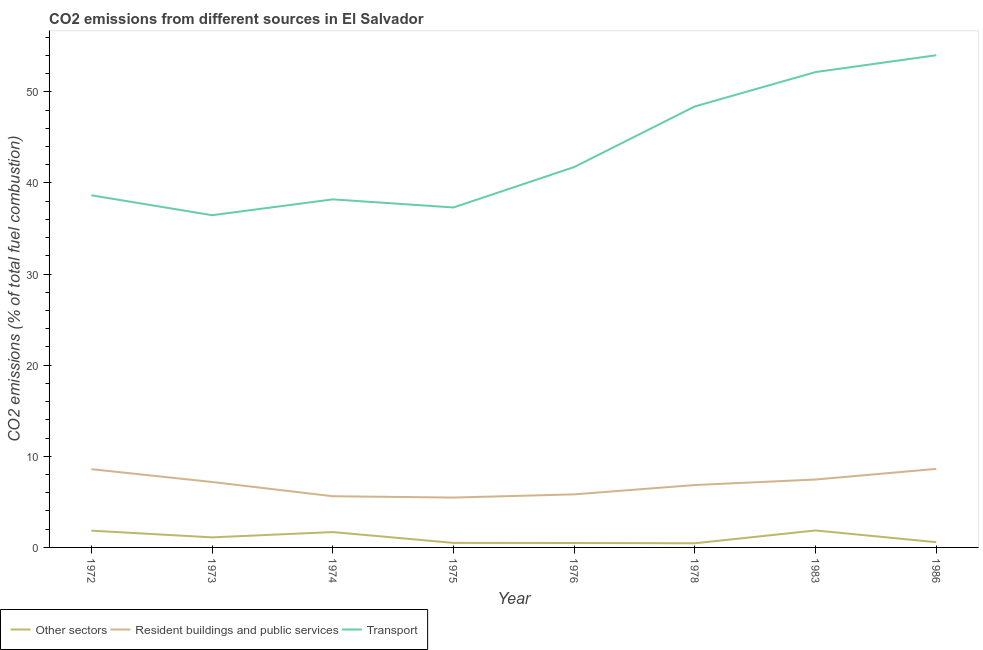How many different coloured lines are there?
Your answer should be compact. 3. Does the line corresponding to percentage of co2 emissions from transport intersect with the line corresponding to percentage of co2 emissions from other sectors?
Keep it short and to the point. No. What is the percentage of co2 emissions from other sectors in 1976?
Your answer should be very brief. 0.49. Across all years, what is the maximum percentage of co2 emissions from resident buildings and public services?
Your answer should be very brief. 8.62. Across all years, what is the minimum percentage of co2 emissions from resident buildings and public services?
Your answer should be very brief. 5.47. In which year was the percentage of co2 emissions from resident buildings and public services minimum?
Ensure brevity in your answer.  1975. What is the total percentage of co2 emissions from transport in the graph?
Ensure brevity in your answer.  346.98. What is the difference between the percentage of co2 emissions from transport in 1978 and that in 1986?
Offer a terse response. -5.62. What is the difference between the percentage of co2 emissions from resident buildings and public services in 1986 and the percentage of co2 emissions from other sectors in 1975?
Provide a succinct answer. 8.12. What is the average percentage of co2 emissions from resident buildings and public services per year?
Your response must be concise. 6.95. In the year 1972, what is the difference between the percentage of co2 emissions from resident buildings and public services and percentage of co2 emissions from other sectors?
Your response must be concise. 6.75. In how many years, is the percentage of co2 emissions from resident buildings and public services greater than 12 %?
Your answer should be very brief. 0. What is the ratio of the percentage of co2 emissions from transport in 1974 to that in 1983?
Offer a terse response. 0.73. Is the percentage of co2 emissions from transport in 1972 less than that in 1986?
Give a very brief answer. Yes. What is the difference between the highest and the second highest percentage of co2 emissions from other sectors?
Give a very brief answer. 0.02. What is the difference between the highest and the lowest percentage of co2 emissions from other sectors?
Ensure brevity in your answer.  1.41. In how many years, is the percentage of co2 emissions from resident buildings and public services greater than the average percentage of co2 emissions from resident buildings and public services taken over all years?
Give a very brief answer. 4. Is it the case that in every year, the sum of the percentage of co2 emissions from other sectors and percentage of co2 emissions from resident buildings and public services is greater than the percentage of co2 emissions from transport?
Give a very brief answer. No. Does the percentage of co2 emissions from transport monotonically increase over the years?
Offer a terse response. No. Is the percentage of co2 emissions from resident buildings and public services strictly greater than the percentage of co2 emissions from other sectors over the years?
Offer a terse response. Yes. Is the percentage of co2 emissions from other sectors strictly less than the percentage of co2 emissions from transport over the years?
Keep it short and to the point. Yes. How many years are there in the graph?
Give a very brief answer. 8. Does the graph contain any zero values?
Offer a very short reply. No. Does the graph contain grids?
Ensure brevity in your answer.  No. Where does the legend appear in the graph?
Your answer should be very brief. Bottom left. How many legend labels are there?
Offer a very short reply. 3. What is the title of the graph?
Ensure brevity in your answer.  CO2 emissions from different sources in El Salvador. What is the label or title of the Y-axis?
Your answer should be compact. CO2 emissions (% of total fuel combustion). What is the CO2 emissions (% of total fuel combustion) of Other sectors in 1972?
Provide a short and direct response. 1.84. What is the CO2 emissions (% of total fuel combustion) in Resident buildings and public services in 1972?
Offer a terse response. 8.59. What is the CO2 emissions (% of total fuel combustion) in Transport in 1972?
Offer a terse response. 38.65. What is the CO2 emissions (% of total fuel combustion) of Other sectors in 1973?
Provide a succinct answer. 1.1. What is the CO2 emissions (% of total fuel combustion) in Resident buildings and public services in 1973?
Your response must be concise. 7.18. What is the CO2 emissions (% of total fuel combustion) in Transport in 1973?
Give a very brief answer. 36.46. What is the CO2 emissions (% of total fuel combustion) in Other sectors in 1974?
Your answer should be compact. 1.69. What is the CO2 emissions (% of total fuel combustion) in Resident buildings and public services in 1974?
Give a very brief answer. 5.62. What is the CO2 emissions (% of total fuel combustion) in Transport in 1974?
Offer a terse response. 38.2. What is the CO2 emissions (% of total fuel combustion) of Other sectors in 1975?
Ensure brevity in your answer.  0.5. What is the CO2 emissions (% of total fuel combustion) of Resident buildings and public services in 1975?
Offer a terse response. 5.47. What is the CO2 emissions (% of total fuel combustion) in Transport in 1975?
Your answer should be very brief. 37.31. What is the CO2 emissions (% of total fuel combustion) of Other sectors in 1976?
Your answer should be compact. 0.49. What is the CO2 emissions (% of total fuel combustion) of Resident buildings and public services in 1976?
Provide a short and direct response. 5.83. What is the CO2 emissions (% of total fuel combustion) in Transport in 1976?
Your response must be concise. 41.75. What is the CO2 emissions (% of total fuel combustion) in Other sectors in 1978?
Offer a terse response. 0.46. What is the CO2 emissions (% of total fuel combustion) in Resident buildings and public services in 1978?
Provide a short and direct response. 6.85. What is the CO2 emissions (% of total fuel combustion) of Transport in 1978?
Your answer should be very brief. 48.4. What is the CO2 emissions (% of total fuel combustion) of Other sectors in 1983?
Make the answer very short. 1.86. What is the CO2 emissions (% of total fuel combustion) of Resident buildings and public services in 1983?
Offer a very short reply. 7.45. What is the CO2 emissions (% of total fuel combustion) of Transport in 1983?
Make the answer very short. 52.17. What is the CO2 emissions (% of total fuel combustion) in Other sectors in 1986?
Offer a terse response. 0.57. What is the CO2 emissions (% of total fuel combustion) in Resident buildings and public services in 1986?
Give a very brief answer. 8.62. What is the CO2 emissions (% of total fuel combustion) of Transport in 1986?
Give a very brief answer. 54.02. Across all years, what is the maximum CO2 emissions (% of total fuel combustion) in Other sectors?
Your answer should be very brief. 1.86. Across all years, what is the maximum CO2 emissions (% of total fuel combustion) of Resident buildings and public services?
Offer a very short reply. 8.62. Across all years, what is the maximum CO2 emissions (% of total fuel combustion) in Transport?
Give a very brief answer. 54.02. Across all years, what is the minimum CO2 emissions (% of total fuel combustion) of Other sectors?
Provide a short and direct response. 0.46. Across all years, what is the minimum CO2 emissions (% of total fuel combustion) in Resident buildings and public services?
Offer a very short reply. 5.47. Across all years, what is the minimum CO2 emissions (% of total fuel combustion) in Transport?
Your answer should be compact. 36.46. What is the total CO2 emissions (% of total fuel combustion) of Other sectors in the graph?
Offer a very short reply. 8.51. What is the total CO2 emissions (% of total fuel combustion) of Resident buildings and public services in the graph?
Provide a succinct answer. 55.61. What is the total CO2 emissions (% of total fuel combustion) of Transport in the graph?
Make the answer very short. 346.98. What is the difference between the CO2 emissions (% of total fuel combustion) of Other sectors in 1972 and that in 1973?
Provide a short and direct response. 0.74. What is the difference between the CO2 emissions (% of total fuel combustion) of Resident buildings and public services in 1972 and that in 1973?
Keep it short and to the point. 1.41. What is the difference between the CO2 emissions (% of total fuel combustion) of Transport in 1972 and that in 1973?
Provide a short and direct response. 2.19. What is the difference between the CO2 emissions (% of total fuel combustion) of Other sectors in 1972 and that in 1974?
Provide a short and direct response. 0.16. What is the difference between the CO2 emissions (% of total fuel combustion) of Resident buildings and public services in 1972 and that in 1974?
Make the answer very short. 2.97. What is the difference between the CO2 emissions (% of total fuel combustion) in Transport in 1972 and that in 1974?
Keep it short and to the point. 0.45. What is the difference between the CO2 emissions (% of total fuel combustion) of Other sectors in 1972 and that in 1975?
Ensure brevity in your answer.  1.34. What is the difference between the CO2 emissions (% of total fuel combustion) of Resident buildings and public services in 1972 and that in 1975?
Make the answer very short. 3.12. What is the difference between the CO2 emissions (% of total fuel combustion) in Transport in 1972 and that in 1975?
Keep it short and to the point. 1.34. What is the difference between the CO2 emissions (% of total fuel combustion) in Other sectors in 1972 and that in 1976?
Your answer should be very brief. 1.36. What is the difference between the CO2 emissions (% of total fuel combustion) in Resident buildings and public services in 1972 and that in 1976?
Ensure brevity in your answer.  2.76. What is the difference between the CO2 emissions (% of total fuel combustion) of Transport in 1972 and that in 1976?
Ensure brevity in your answer.  -3.1. What is the difference between the CO2 emissions (% of total fuel combustion) of Other sectors in 1972 and that in 1978?
Provide a succinct answer. 1.38. What is the difference between the CO2 emissions (% of total fuel combustion) in Resident buildings and public services in 1972 and that in 1978?
Offer a very short reply. 1.74. What is the difference between the CO2 emissions (% of total fuel combustion) of Transport in 1972 and that in 1978?
Provide a succinct answer. -9.75. What is the difference between the CO2 emissions (% of total fuel combustion) of Other sectors in 1972 and that in 1983?
Offer a terse response. -0.02. What is the difference between the CO2 emissions (% of total fuel combustion) of Resident buildings and public services in 1972 and that in 1983?
Make the answer very short. 1.14. What is the difference between the CO2 emissions (% of total fuel combustion) of Transport in 1972 and that in 1983?
Your answer should be very brief. -13.52. What is the difference between the CO2 emissions (% of total fuel combustion) of Other sectors in 1972 and that in 1986?
Offer a terse response. 1.27. What is the difference between the CO2 emissions (% of total fuel combustion) in Resident buildings and public services in 1972 and that in 1986?
Your answer should be very brief. -0.03. What is the difference between the CO2 emissions (% of total fuel combustion) in Transport in 1972 and that in 1986?
Provide a succinct answer. -15.37. What is the difference between the CO2 emissions (% of total fuel combustion) in Other sectors in 1973 and that in 1974?
Ensure brevity in your answer.  -0.58. What is the difference between the CO2 emissions (% of total fuel combustion) of Resident buildings and public services in 1973 and that in 1974?
Give a very brief answer. 1.56. What is the difference between the CO2 emissions (% of total fuel combustion) in Transport in 1973 and that in 1974?
Offer a terse response. -1.74. What is the difference between the CO2 emissions (% of total fuel combustion) of Other sectors in 1973 and that in 1975?
Keep it short and to the point. 0.61. What is the difference between the CO2 emissions (% of total fuel combustion) of Resident buildings and public services in 1973 and that in 1975?
Make the answer very short. 1.71. What is the difference between the CO2 emissions (% of total fuel combustion) of Transport in 1973 and that in 1975?
Make the answer very short. -0.85. What is the difference between the CO2 emissions (% of total fuel combustion) of Other sectors in 1973 and that in 1976?
Ensure brevity in your answer.  0.62. What is the difference between the CO2 emissions (% of total fuel combustion) in Resident buildings and public services in 1973 and that in 1976?
Ensure brevity in your answer.  1.36. What is the difference between the CO2 emissions (% of total fuel combustion) in Transport in 1973 and that in 1976?
Keep it short and to the point. -5.28. What is the difference between the CO2 emissions (% of total fuel combustion) in Other sectors in 1973 and that in 1978?
Your response must be concise. 0.65. What is the difference between the CO2 emissions (% of total fuel combustion) of Resident buildings and public services in 1973 and that in 1978?
Give a very brief answer. 0.33. What is the difference between the CO2 emissions (% of total fuel combustion) of Transport in 1973 and that in 1978?
Make the answer very short. -11.94. What is the difference between the CO2 emissions (% of total fuel combustion) of Other sectors in 1973 and that in 1983?
Ensure brevity in your answer.  -0.76. What is the difference between the CO2 emissions (% of total fuel combustion) of Resident buildings and public services in 1973 and that in 1983?
Provide a short and direct response. -0.27. What is the difference between the CO2 emissions (% of total fuel combustion) of Transport in 1973 and that in 1983?
Your answer should be compact. -15.71. What is the difference between the CO2 emissions (% of total fuel combustion) in Other sectors in 1973 and that in 1986?
Your answer should be compact. 0.53. What is the difference between the CO2 emissions (% of total fuel combustion) of Resident buildings and public services in 1973 and that in 1986?
Make the answer very short. -1.44. What is the difference between the CO2 emissions (% of total fuel combustion) of Transport in 1973 and that in 1986?
Offer a terse response. -17.56. What is the difference between the CO2 emissions (% of total fuel combustion) in Other sectors in 1974 and that in 1975?
Provide a short and direct response. 1.19. What is the difference between the CO2 emissions (% of total fuel combustion) of Resident buildings and public services in 1974 and that in 1975?
Offer a terse response. 0.15. What is the difference between the CO2 emissions (% of total fuel combustion) of Transport in 1974 and that in 1975?
Offer a very short reply. 0.89. What is the difference between the CO2 emissions (% of total fuel combustion) in Other sectors in 1974 and that in 1976?
Your answer should be compact. 1.2. What is the difference between the CO2 emissions (% of total fuel combustion) of Resident buildings and public services in 1974 and that in 1976?
Provide a succinct answer. -0.21. What is the difference between the CO2 emissions (% of total fuel combustion) of Transport in 1974 and that in 1976?
Keep it short and to the point. -3.55. What is the difference between the CO2 emissions (% of total fuel combustion) of Other sectors in 1974 and that in 1978?
Your answer should be very brief. 1.23. What is the difference between the CO2 emissions (% of total fuel combustion) of Resident buildings and public services in 1974 and that in 1978?
Keep it short and to the point. -1.23. What is the difference between the CO2 emissions (% of total fuel combustion) of Transport in 1974 and that in 1978?
Provide a short and direct response. -10.2. What is the difference between the CO2 emissions (% of total fuel combustion) of Other sectors in 1974 and that in 1983?
Your answer should be very brief. -0.18. What is the difference between the CO2 emissions (% of total fuel combustion) of Resident buildings and public services in 1974 and that in 1983?
Your answer should be compact. -1.84. What is the difference between the CO2 emissions (% of total fuel combustion) in Transport in 1974 and that in 1983?
Keep it short and to the point. -13.97. What is the difference between the CO2 emissions (% of total fuel combustion) in Other sectors in 1974 and that in 1986?
Ensure brevity in your answer.  1.11. What is the difference between the CO2 emissions (% of total fuel combustion) in Resident buildings and public services in 1974 and that in 1986?
Offer a very short reply. -3. What is the difference between the CO2 emissions (% of total fuel combustion) of Transport in 1974 and that in 1986?
Your response must be concise. -15.82. What is the difference between the CO2 emissions (% of total fuel combustion) of Other sectors in 1975 and that in 1976?
Your answer should be very brief. 0.01. What is the difference between the CO2 emissions (% of total fuel combustion) of Resident buildings and public services in 1975 and that in 1976?
Provide a short and direct response. -0.35. What is the difference between the CO2 emissions (% of total fuel combustion) of Transport in 1975 and that in 1976?
Your response must be concise. -4.43. What is the difference between the CO2 emissions (% of total fuel combustion) in Other sectors in 1975 and that in 1978?
Your response must be concise. 0.04. What is the difference between the CO2 emissions (% of total fuel combustion) in Resident buildings and public services in 1975 and that in 1978?
Offer a terse response. -1.38. What is the difference between the CO2 emissions (% of total fuel combustion) in Transport in 1975 and that in 1978?
Provide a succinct answer. -11.09. What is the difference between the CO2 emissions (% of total fuel combustion) in Other sectors in 1975 and that in 1983?
Give a very brief answer. -1.37. What is the difference between the CO2 emissions (% of total fuel combustion) in Resident buildings and public services in 1975 and that in 1983?
Provide a short and direct response. -1.98. What is the difference between the CO2 emissions (% of total fuel combustion) in Transport in 1975 and that in 1983?
Keep it short and to the point. -14.86. What is the difference between the CO2 emissions (% of total fuel combustion) in Other sectors in 1975 and that in 1986?
Make the answer very short. -0.08. What is the difference between the CO2 emissions (% of total fuel combustion) of Resident buildings and public services in 1975 and that in 1986?
Keep it short and to the point. -3.15. What is the difference between the CO2 emissions (% of total fuel combustion) in Transport in 1975 and that in 1986?
Your response must be concise. -16.71. What is the difference between the CO2 emissions (% of total fuel combustion) in Other sectors in 1976 and that in 1978?
Your response must be concise. 0.03. What is the difference between the CO2 emissions (% of total fuel combustion) in Resident buildings and public services in 1976 and that in 1978?
Give a very brief answer. -1.02. What is the difference between the CO2 emissions (% of total fuel combustion) of Transport in 1976 and that in 1978?
Your response must be concise. -6.65. What is the difference between the CO2 emissions (% of total fuel combustion) of Other sectors in 1976 and that in 1983?
Your answer should be compact. -1.38. What is the difference between the CO2 emissions (% of total fuel combustion) of Resident buildings and public services in 1976 and that in 1983?
Offer a terse response. -1.63. What is the difference between the CO2 emissions (% of total fuel combustion) in Transport in 1976 and that in 1983?
Your response must be concise. -10.43. What is the difference between the CO2 emissions (% of total fuel combustion) of Other sectors in 1976 and that in 1986?
Your answer should be very brief. -0.09. What is the difference between the CO2 emissions (% of total fuel combustion) in Resident buildings and public services in 1976 and that in 1986?
Offer a terse response. -2.8. What is the difference between the CO2 emissions (% of total fuel combustion) of Transport in 1976 and that in 1986?
Keep it short and to the point. -12.28. What is the difference between the CO2 emissions (% of total fuel combustion) in Other sectors in 1978 and that in 1983?
Offer a terse response. -1.41. What is the difference between the CO2 emissions (% of total fuel combustion) of Resident buildings and public services in 1978 and that in 1983?
Offer a very short reply. -0.6. What is the difference between the CO2 emissions (% of total fuel combustion) of Transport in 1978 and that in 1983?
Keep it short and to the point. -3.77. What is the difference between the CO2 emissions (% of total fuel combustion) of Other sectors in 1978 and that in 1986?
Offer a terse response. -0.12. What is the difference between the CO2 emissions (% of total fuel combustion) of Resident buildings and public services in 1978 and that in 1986?
Give a very brief answer. -1.77. What is the difference between the CO2 emissions (% of total fuel combustion) of Transport in 1978 and that in 1986?
Make the answer very short. -5.62. What is the difference between the CO2 emissions (% of total fuel combustion) in Other sectors in 1983 and that in 1986?
Offer a terse response. 1.29. What is the difference between the CO2 emissions (% of total fuel combustion) in Resident buildings and public services in 1983 and that in 1986?
Offer a very short reply. -1.17. What is the difference between the CO2 emissions (% of total fuel combustion) in Transport in 1983 and that in 1986?
Make the answer very short. -1.85. What is the difference between the CO2 emissions (% of total fuel combustion) of Other sectors in 1972 and the CO2 emissions (% of total fuel combustion) of Resident buildings and public services in 1973?
Ensure brevity in your answer.  -5.34. What is the difference between the CO2 emissions (% of total fuel combustion) of Other sectors in 1972 and the CO2 emissions (% of total fuel combustion) of Transport in 1973?
Ensure brevity in your answer.  -34.62. What is the difference between the CO2 emissions (% of total fuel combustion) of Resident buildings and public services in 1972 and the CO2 emissions (% of total fuel combustion) of Transport in 1973?
Offer a terse response. -27.88. What is the difference between the CO2 emissions (% of total fuel combustion) of Other sectors in 1972 and the CO2 emissions (% of total fuel combustion) of Resident buildings and public services in 1974?
Ensure brevity in your answer.  -3.78. What is the difference between the CO2 emissions (% of total fuel combustion) in Other sectors in 1972 and the CO2 emissions (% of total fuel combustion) in Transport in 1974?
Provide a succinct answer. -36.36. What is the difference between the CO2 emissions (% of total fuel combustion) of Resident buildings and public services in 1972 and the CO2 emissions (% of total fuel combustion) of Transport in 1974?
Offer a terse response. -29.61. What is the difference between the CO2 emissions (% of total fuel combustion) in Other sectors in 1972 and the CO2 emissions (% of total fuel combustion) in Resident buildings and public services in 1975?
Your answer should be compact. -3.63. What is the difference between the CO2 emissions (% of total fuel combustion) of Other sectors in 1972 and the CO2 emissions (% of total fuel combustion) of Transport in 1975?
Provide a short and direct response. -35.47. What is the difference between the CO2 emissions (% of total fuel combustion) in Resident buildings and public services in 1972 and the CO2 emissions (% of total fuel combustion) in Transport in 1975?
Keep it short and to the point. -28.72. What is the difference between the CO2 emissions (% of total fuel combustion) in Other sectors in 1972 and the CO2 emissions (% of total fuel combustion) in Resident buildings and public services in 1976?
Provide a short and direct response. -3.98. What is the difference between the CO2 emissions (% of total fuel combustion) in Other sectors in 1972 and the CO2 emissions (% of total fuel combustion) in Transport in 1976?
Your answer should be very brief. -39.91. What is the difference between the CO2 emissions (% of total fuel combustion) of Resident buildings and public services in 1972 and the CO2 emissions (% of total fuel combustion) of Transport in 1976?
Provide a short and direct response. -33.16. What is the difference between the CO2 emissions (% of total fuel combustion) of Other sectors in 1972 and the CO2 emissions (% of total fuel combustion) of Resident buildings and public services in 1978?
Offer a terse response. -5.01. What is the difference between the CO2 emissions (% of total fuel combustion) of Other sectors in 1972 and the CO2 emissions (% of total fuel combustion) of Transport in 1978?
Provide a short and direct response. -46.56. What is the difference between the CO2 emissions (% of total fuel combustion) in Resident buildings and public services in 1972 and the CO2 emissions (% of total fuel combustion) in Transport in 1978?
Ensure brevity in your answer.  -39.81. What is the difference between the CO2 emissions (% of total fuel combustion) of Other sectors in 1972 and the CO2 emissions (% of total fuel combustion) of Resident buildings and public services in 1983?
Give a very brief answer. -5.61. What is the difference between the CO2 emissions (% of total fuel combustion) of Other sectors in 1972 and the CO2 emissions (% of total fuel combustion) of Transport in 1983?
Provide a succinct answer. -50.33. What is the difference between the CO2 emissions (% of total fuel combustion) in Resident buildings and public services in 1972 and the CO2 emissions (% of total fuel combustion) in Transport in 1983?
Your answer should be very brief. -43.59. What is the difference between the CO2 emissions (% of total fuel combustion) in Other sectors in 1972 and the CO2 emissions (% of total fuel combustion) in Resident buildings and public services in 1986?
Your answer should be very brief. -6.78. What is the difference between the CO2 emissions (% of total fuel combustion) of Other sectors in 1972 and the CO2 emissions (% of total fuel combustion) of Transport in 1986?
Make the answer very short. -52.18. What is the difference between the CO2 emissions (% of total fuel combustion) in Resident buildings and public services in 1972 and the CO2 emissions (% of total fuel combustion) in Transport in 1986?
Your answer should be very brief. -45.43. What is the difference between the CO2 emissions (% of total fuel combustion) in Other sectors in 1973 and the CO2 emissions (% of total fuel combustion) in Resident buildings and public services in 1974?
Provide a short and direct response. -4.51. What is the difference between the CO2 emissions (% of total fuel combustion) in Other sectors in 1973 and the CO2 emissions (% of total fuel combustion) in Transport in 1974?
Keep it short and to the point. -37.1. What is the difference between the CO2 emissions (% of total fuel combustion) in Resident buildings and public services in 1973 and the CO2 emissions (% of total fuel combustion) in Transport in 1974?
Offer a terse response. -31.02. What is the difference between the CO2 emissions (% of total fuel combustion) in Other sectors in 1973 and the CO2 emissions (% of total fuel combustion) in Resident buildings and public services in 1975?
Offer a very short reply. -4.37. What is the difference between the CO2 emissions (% of total fuel combustion) of Other sectors in 1973 and the CO2 emissions (% of total fuel combustion) of Transport in 1975?
Ensure brevity in your answer.  -36.21. What is the difference between the CO2 emissions (% of total fuel combustion) in Resident buildings and public services in 1973 and the CO2 emissions (% of total fuel combustion) in Transport in 1975?
Your response must be concise. -30.13. What is the difference between the CO2 emissions (% of total fuel combustion) in Other sectors in 1973 and the CO2 emissions (% of total fuel combustion) in Resident buildings and public services in 1976?
Offer a terse response. -4.72. What is the difference between the CO2 emissions (% of total fuel combustion) of Other sectors in 1973 and the CO2 emissions (% of total fuel combustion) of Transport in 1976?
Ensure brevity in your answer.  -40.64. What is the difference between the CO2 emissions (% of total fuel combustion) of Resident buildings and public services in 1973 and the CO2 emissions (% of total fuel combustion) of Transport in 1976?
Your response must be concise. -34.57. What is the difference between the CO2 emissions (% of total fuel combustion) in Other sectors in 1973 and the CO2 emissions (% of total fuel combustion) in Resident buildings and public services in 1978?
Give a very brief answer. -5.74. What is the difference between the CO2 emissions (% of total fuel combustion) of Other sectors in 1973 and the CO2 emissions (% of total fuel combustion) of Transport in 1978?
Your answer should be very brief. -47.3. What is the difference between the CO2 emissions (% of total fuel combustion) of Resident buildings and public services in 1973 and the CO2 emissions (% of total fuel combustion) of Transport in 1978?
Ensure brevity in your answer.  -41.22. What is the difference between the CO2 emissions (% of total fuel combustion) of Other sectors in 1973 and the CO2 emissions (% of total fuel combustion) of Resident buildings and public services in 1983?
Offer a terse response. -6.35. What is the difference between the CO2 emissions (% of total fuel combustion) of Other sectors in 1973 and the CO2 emissions (% of total fuel combustion) of Transport in 1983?
Your response must be concise. -51.07. What is the difference between the CO2 emissions (% of total fuel combustion) of Resident buildings and public services in 1973 and the CO2 emissions (% of total fuel combustion) of Transport in 1983?
Offer a terse response. -44.99. What is the difference between the CO2 emissions (% of total fuel combustion) of Other sectors in 1973 and the CO2 emissions (% of total fuel combustion) of Resident buildings and public services in 1986?
Your answer should be compact. -7.52. What is the difference between the CO2 emissions (% of total fuel combustion) of Other sectors in 1973 and the CO2 emissions (% of total fuel combustion) of Transport in 1986?
Your response must be concise. -52.92. What is the difference between the CO2 emissions (% of total fuel combustion) in Resident buildings and public services in 1973 and the CO2 emissions (% of total fuel combustion) in Transport in 1986?
Offer a terse response. -46.84. What is the difference between the CO2 emissions (% of total fuel combustion) in Other sectors in 1974 and the CO2 emissions (% of total fuel combustion) in Resident buildings and public services in 1975?
Your answer should be compact. -3.79. What is the difference between the CO2 emissions (% of total fuel combustion) of Other sectors in 1974 and the CO2 emissions (% of total fuel combustion) of Transport in 1975?
Provide a short and direct response. -35.63. What is the difference between the CO2 emissions (% of total fuel combustion) in Resident buildings and public services in 1974 and the CO2 emissions (% of total fuel combustion) in Transport in 1975?
Your answer should be compact. -31.7. What is the difference between the CO2 emissions (% of total fuel combustion) of Other sectors in 1974 and the CO2 emissions (% of total fuel combustion) of Resident buildings and public services in 1976?
Give a very brief answer. -4.14. What is the difference between the CO2 emissions (% of total fuel combustion) of Other sectors in 1974 and the CO2 emissions (% of total fuel combustion) of Transport in 1976?
Provide a short and direct response. -40.06. What is the difference between the CO2 emissions (% of total fuel combustion) of Resident buildings and public services in 1974 and the CO2 emissions (% of total fuel combustion) of Transport in 1976?
Your response must be concise. -36.13. What is the difference between the CO2 emissions (% of total fuel combustion) of Other sectors in 1974 and the CO2 emissions (% of total fuel combustion) of Resident buildings and public services in 1978?
Your answer should be very brief. -5.16. What is the difference between the CO2 emissions (% of total fuel combustion) in Other sectors in 1974 and the CO2 emissions (% of total fuel combustion) in Transport in 1978?
Your answer should be compact. -46.72. What is the difference between the CO2 emissions (% of total fuel combustion) in Resident buildings and public services in 1974 and the CO2 emissions (% of total fuel combustion) in Transport in 1978?
Provide a succinct answer. -42.78. What is the difference between the CO2 emissions (% of total fuel combustion) of Other sectors in 1974 and the CO2 emissions (% of total fuel combustion) of Resident buildings and public services in 1983?
Offer a terse response. -5.77. What is the difference between the CO2 emissions (% of total fuel combustion) in Other sectors in 1974 and the CO2 emissions (% of total fuel combustion) in Transport in 1983?
Give a very brief answer. -50.49. What is the difference between the CO2 emissions (% of total fuel combustion) in Resident buildings and public services in 1974 and the CO2 emissions (% of total fuel combustion) in Transport in 1983?
Keep it short and to the point. -46.56. What is the difference between the CO2 emissions (% of total fuel combustion) in Other sectors in 1974 and the CO2 emissions (% of total fuel combustion) in Resident buildings and public services in 1986?
Offer a terse response. -6.94. What is the difference between the CO2 emissions (% of total fuel combustion) of Other sectors in 1974 and the CO2 emissions (% of total fuel combustion) of Transport in 1986?
Offer a terse response. -52.34. What is the difference between the CO2 emissions (% of total fuel combustion) in Resident buildings and public services in 1974 and the CO2 emissions (% of total fuel combustion) in Transport in 1986?
Provide a succinct answer. -48.41. What is the difference between the CO2 emissions (% of total fuel combustion) of Other sectors in 1975 and the CO2 emissions (% of total fuel combustion) of Resident buildings and public services in 1976?
Give a very brief answer. -5.33. What is the difference between the CO2 emissions (% of total fuel combustion) of Other sectors in 1975 and the CO2 emissions (% of total fuel combustion) of Transport in 1976?
Your answer should be compact. -41.25. What is the difference between the CO2 emissions (% of total fuel combustion) of Resident buildings and public services in 1975 and the CO2 emissions (% of total fuel combustion) of Transport in 1976?
Your answer should be very brief. -36.27. What is the difference between the CO2 emissions (% of total fuel combustion) in Other sectors in 1975 and the CO2 emissions (% of total fuel combustion) in Resident buildings and public services in 1978?
Make the answer very short. -6.35. What is the difference between the CO2 emissions (% of total fuel combustion) in Other sectors in 1975 and the CO2 emissions (% of total fuel combustion) in Transport in 1978?
Provide a short and direct response. -47.9. What is the difference between the CO2 emissions (% of total fuel combustion) in Resident buildings and public services in 1975 and the CO2 emissions (% of total fuel combustion) in Transport in 1978?
Ensure brevity in your answer.  -42.93. What is the difference between the CO2 emissions (% of total fuel combustion) of Other sectors in 1975 and the CO2 emissions (% of total fuel combustion) of Resident buildings and public services in 1983?
Keep it short and to the point. -6.96. What is the difference between the CO2 emissions (% of total fuel combustion) in Other sectors in 1975 and the CO2 emissions (% of total fuel combustion) in Transport in 1983?
Provide a short and direct response. -51.68. What is the difference between the CO2 emissions (% of total fuel combustion) in Resident buildings and public services in 1975 and the CO2 emissions (% of total fuel combustion) in Transport in 1983?
Your answer should be very brief. -46.7. What is the difference between the CO2 emissions (% of total fuel combustion) of Other sectors in 1975 and the CO2 emissions (% of total fuel combustion) of Resident buildings and public services in 1986?
Offer a very short reply. -8.12. What is the difference between the CO2 emissions (% of total fuel combustion) in Other sectors in 1975 and the CO2 emissions (% of total fuel combustion) in Transport in 1986?
Your response must be concise. -53.53. What is the difference between the CO2 emissions (% of total fuel combustion) in Resident buildings and public services in 1975 and the CO2 emissions (% of total fuel combustion) in Transport in 1986?
Offer a terse response. -48.55. What is the difference between the CO2 emissions (% of total fuel combustion) in Other sectors in 1976 and the CO2 emissions (% of total fuel combustion) in Resident buildings and public services in 1978?
Ensure brevity in your answer.  -6.36. What is the difference between the CO2 emissions (% of total fuel combustion) of Other sectors in 1976 and the CO2 emissions (% of total fuel combustion) of Transport in 1978?
Offer a terse response. -47.92. What is the difference between the CO2 emissions (% of total fuel combustion) of Resident buildings and public services in 1976 and the CO2 emissions (% of total fuel combustion) of Transport in 1978?
Offer a terse response. -42.58. What is the difference between the CO2 emissions (% of total fuel combustion) of Other sectors in 1976 and the CO2 emissions (% of total fuel combustion) of Resident buildings and public services in 1983?
Your answer should be compact. -6.97. What is the difference between the CO2 emissions (% of total fuel combustion) of Other sectors in 1976 and the CO2 emissions (% of total fuel combustion) of Transport in 1983?
Offer a terse response. -51.69. What is the difference between the CO2 emissions (% of total fuel combustion) in Resident buildings and public services in 1976 and the CO2 emissions (% of total fuel combustion) in Transport in 1983?
Provide a succinct answer. -46.35. What is the difference between the CO2 emissions (% of total fuel combustion) of Other sectors in 1976 and the CO2 emissions (% of total fuel combustion) of Resident buildings and public services in 1986?
Ensure brevity in your answer.  -8.14. What is the difference between the CO2 emissions (% of total fuel combustion) of Other sectors in 1976 and the CO2 emissions (% of total fuel combustion) of Transport in 1986?
Offer a very short reply. -53.54. What is the difference between the CO2 emissions (% of total fuel combustion) of Resident buildings and public services in 1976 and the CO2 emissions (% of total fuel combustion) of Transport in 1986?
Your answer should be compact. -48.2. What is the difference between the CO2 emissions (% of total fuel combustion) of Other sectors in 1978 and the CO2 emissions (% of total fuel combustion) of Resident buildings and public services in 1983?
Give a very brief answer. -7. What is the difference between the CO2 emissions (% of total fuel combustion) in Other sectors in 1978 and the CO2 emissions (% of total fuel combustion) in Transport in 1983?
Your answer should be compact. -51.72. What is the difference between the CO2 emissions (% of total fuel combustion) in Resident buildings and public services in 1978 and the CO2 emissions (% of total fuel combustion) in Transport in 1983?
Offer a very short reply. -45.32. What is the difference between the CO2 emissions (% of total fuel combustion) of Other sectors in 1978 and the CO2 emissions (% of total fuel combustion) of Resident buildings and public services in 1986?
Give a very brief answer. -8.16. What is the difference between the CO2 emissions (% of total fuel combustion) of Other sectors in 1978 and the CO2 emissions (% of total fuel combustion) of Transport in 1986?
Give a very brief answer. -53.57. What is the difference between the CO2 emissions (% of total fuel combustion) in Resident buildings and public services in 1978 and the CO2 emissions (% of total fuel combustion) in Transport in 1986?
Give a very brief answer. -47.17. What is the difference between the CO2 emissions (% of total fuel combustion) in Other sectors in 1983 and the CO2 emissions (% of total fuel combustion) in Resident buildings and public services in 1986?
Ensure brevity in your answer.  -6.76. What is the difference between the CO2 emissions (% of total fuel combustion) in Other sectors in 1983 and the CO2 emissions (% of total fuel combustion) in Transport in 1986?
Give a very brief answer. -52.16. What is the difference between the CO2 emissions (% of total fuel combustion) of Resident buildings and public services in 1983 and the CO2 emissions (% of total fuel combustion) of Transport in 1986?
Keep it short and to the point. -46.57. What is the average CO2 emissions (% of total fuel combustion) of Other sectors per year?
Keep it short and to the point. 1.06. What is the average CO2 emissions (% of total fuel combustion) of Resident buildings and public services per year?
Give a very brief answer. 6.95. What is the average CO2 emissions (% of total fuel combustion) in Transport per year?
Your response must be concise. 43.37. In the year 1972, what is the difference between the CO2 emissions (% of total fuel combustion) of Other sectors and CO2 emissions (% of total fuel combustion) of Resident buildings and public services?
Your answer should be very brief. -6.75. In the year 1972, what is the difference between the CO2 emissions (% of total fuel combustion) of Other sectors and CO2 emissions (% of total fuel combustion) of Transport?
Your answer should be very brief. -36.81. In the year 1972, what is the difference between the CO2 emissions (% of total fuel combustion) in Resident buildings and public services and CO2 emissions (% of total fuel combustion) in Transport?
Your response must be concise. -30.06. In the year 1973, what is the difference between the CO2 emissions (% of total fuel combustion) in Other sectors and CO2 emissions (% of total fuel combustion) in Resident buildings and public services?
Provide a short and direct response. -6.08. In the year 1973, what is the difference between the CO2 emissions (% of total fuel combustion) in Other sectors and CO2 emissions (% of total fuel combustion) in Transport?
Provide a succinct answer. -35.36. In the year 1973, what is the difference between the CO2 emissions (% of total fuel combustion) of Resident buildings and public services and CO2 emissions (% of total fuel combustion) of Transport?
Offer a very short reply. -29.28. In the year 1974, what is the difference between the CO2 emissions (% of total fuel combustion) in Other sectors and CO2 emissions (% of total fuel combustion) in Resident buildings and public services?
Offer a terse response. -3.93. In the year 1974, what is the difference between the CO2 emissions (% of total fuel combustion) of Other sectors and CO2 emissions (% of total fuel combustion) of Transport?
Provide a short and direct response. -36.52. In the year 1974, what is the difference between the CO2 emissions (% of total fuel combustion) of Resident buildings and public services and CO2 emissions (% of total fuel combustion) of Transport?
Keep it short and to the point. -32.58. In the year 1975, what is the difference between the CO2 emissions (% of total fuel combustion) of Other sectors and CO2 emissions (% of total fuel combustion) of Resident buildings and public services?
Your response must be concise. -4.98. In the year 1975, what is the difference between the CO2 emissions (% of total fuel combustion) of Other sectors and CO2 emissions (% of total fuel combustion) of Transport?
Provide a short and direct response. -36.82. In the year 1975, what is the difference between the CO2 emissions (% of total fuel combustion) of Resident buildings and public services and CO2 emissions (% of total fuel combustion) of Transport?
Give a very brief answer. -31.84. In the year 1976, what is the difference between the CO2 emissions (% of total fuel combustion) in Other sectors and CO2 emissions (% of total fuel combustion) in Resident buildings and public services?
Offer a very short reply. -5.34. In the year 1976, what is the difference between the CO2 emissions (% of total fuel combustion) of Other sectors and CO2 emissions (% of total fuel combustion) of Transport?
Provide a succinct answer. -41.26. In the year 1976, what is the difference between the CO2 emissions (% of total fuel combustion) of Resident buildings and public services and CO2 emissions (% of total fuel combustion) of Transport?
Ensure brevity in your answer.  -35.92. In the year 1978, what is the difference between the CO2 emissions (% of total fuel combustion) of Other sectors and CO2 emissions (% of total fuel combustion) of Resident buildings and public services?
Make the answer very short. -6.39. In the year 1978, what is the difference between the CO2 emissions (% of total fuel combustion) in Other sectors and CO2 emissions (% of total fuel combustion) in Transport?
Offer a very short reply. -47.95. In the year 1978, what is the difference between the CO2 emissions (% of total fuel combustion) of Resident buildings and public services and CO2 emissions (% of total fuel combustion) of Transport?
Provide a succinct answer. -41.55. In the year 1983, what is the difference between the CO2 emissions (% of total fuel combustion) of Other sectors and CO2 emissions (% of total fuel combustion) of Resident buildings and public services?
Offer a terse response. -5.59. In the year 1983, what is the difference between the CO2 emissions (% of total fuel combustion) in Other sectors and CO2 emissions (% of total fuel combustion) in Transport?
Give a very brief answer. -50.31. In the year 1983, what is the difference between the CO2 emissions (% of total fuel combustion) of Resident buildings and public services and CO2 emissions (% of total fuel combustion) of Transport?
Provide a short and direct response. -44.72. In the year 1986, what is the difference between the CO2 emissions (% of total fuel combustion) in Other sectors and CO2 emissions (% of total fuel combustion) in Resident buildings and public services?
Make the answer very short. -8.05. In the year 1986, what is the difference between the CO2 emissions (% of total fuel combustion) in Other sectors and CO2 emissions (% of total fuel combustion) in Transport?
Keep it short and to the point. -53.45. In the year 1986, what is the difference between the CO2 emissions (% of total fuel combustion) in Resident buildings and public services and CO2 emissions (% of total fuel combustion) in Transport?
Keep it short and to the point. -45.4. What is the ratio of the CO2 emissions (% of total fuel combustion) of Other sectors in 1972 to that in 1973?
Your answer should be very brief. 1.67. What is the ratio of the CO2 emissions (% of total fuel combustion) in Resident buildings and public services in 1972 to that in 1973?
Your response must be concise. 1.2. What is the ratio of the CO2 emissions (% of total fuel combustion) in Transport in 1972 to that in 1973?
Offer a terse response. 1.06. What is the ratio of the CO2 emissions (% of total fuel combustion) of Other sectors in 1972 to that in 1974?
Ensure brevity in your answer.  1.09. What is the ratio of the CO2 emissions (% of total fuel combustion) in Resident buildings and public services in 1972 to that in 1974?
Ensure brevity in your answer.  1.53. What is the ratio of the CO2 emissions (% of total fuel combustion) of Transport in 1972 to that in 1974?
Your answer should be very brief. 1.01. What is the ratio of the CO2 emissions (% of total fuel combustion) of Other sectors in 1972 to that in 1975?
Your answer should be compact. 3.7. What is the ratio of the CO2 emissions (% of total fuel combustion) in Resident buildings and public services in 1972 to that in 1975?
Offer a very short reply. 1.57. What is the ratio of the CO2 emissions (% of total fuel combustion) in Transport in 1972 to that in 1975?
Make the answer very short. 1.04. What is the ratio of the CO2 emissions (% of total fuel combustion) of Other sectors in 1972 to that in 1976?
Offer a terse response. 3.79. What is the ratio of the CO2 emissions (% of total fuel combustion) in Resident buildings and public services in 1972 to that in 1976?
Your answer should be very brief. 1.47. What is the ratio of the CO2 emissions (% of total fuel combustion) of Transport in 1972 to that in 1976?
Keep it short and to the point. 0.93. What is the ratio of the CO2 emissions (% of total fuel combustion) in Other sectors in 1972 to that in 1978?
Provide a succinct answer. 4.03. What is the ratio of the CO2 emissions (% of total fuel combustion) in Resident buildings and public services in 1972 to that in 1978?
Provide a succinct answer. 1.25. What is the ratio of the CO2 emissions (% of total fuel combustion) of Transport in 1972 to that in 1978?
Offer a very short reply. 0.8. What is the ratio of the CO2 emissions (% of total fuel combustion) of Other sectors in 1972 to that in 1983?
Provide a succinct answer. 0.99. What is the ratio of the CO2 emissions (% of total fuel combustion) of Resident buildings and public services in 1972 to that in 1983?
Give a very brief answer. 1.15. What is the ratio of the CO2 emissions (% of total fuel combustion) in Transport in 1972 to that in 1983?
Ensure brevity in your answer.  0.74. What is the ratio of the CO2 emissions (% of total fuel combustion) of Other sectors in 1972 to that in 1986?
Offer a terse response. 3.2. What is the ratio of the CO2 emissions (% of total fuel combustion) of Resident buildings and public services in 1972 to that in 1986?
Your answer should be very brief. 1. What is the ratio of the CO2 emissions (% of total fuel combustion) of Transport in 1972 to that in 1986?
Provide a short and direct response. 0.72. What is the ratio of the CO2 emissions (% of total fuel combustion) in Other sectors in 1973 to that in 1974?
Ensure brevity in your answer.  0.66. What is the ratio of the CO2 emissions (% of total fuel combustion) of Resident buildings and public services in 1973 to that in 1974?
Give a very brief answer. 1.28. What is the ratio of the CO2 emissions (% of total fuel combustion) in Transport in 1973 to that in 1974?
Your answer should be very brief. 0.95. What is the ratio of the CO2 emissions (% of total fuel combustion) in Other sectors in 1973 to that in 1975?
Offer a terse response. 2.22. What is the ratio of the CO2 emissions (% of total fuel combustion) in Resident buildings and public services in 1973 to that in 1975?
Offer a very short reply. 1.31. What is the ratio of the CO2 emissions (% of total fuel combustion) in Transport in 1973 to that in 1975?
Make the answer very short. 0.98. What is the ratio of the CO2 emissions (% of total fuel combustion) in Other sectors in 1973 to that in 1976?
Provide a succinct answer. 2.28. What is the ratio of the CO2 emissions (% of total fuel combustion) in Resident buildings and public services in 1973 to that in 1976?
Offer a very short reply. 1.23. What is the ratio of the CO2 emissions (% of total fuel combustion) of Transport in 1973 to that in 1976?
Your answer should be compact. 0.87. What is the ratio of the CO2 emissions (% of total fuel combustion) of Other sectors in 1973 to that in 1978?
Your answer should be compact. 2.42. What is the ratio of the CO2 emissions (% of total fuel combustion) of Resident buildings and public services in 1973 to that in 1978?
Make the answer very short. 1.05. What is the ratio of the CO2 emissions (% of total fuel combustion) in Transport in 1973 to that in 1978?
Give a very brief answer. 0.75. What is the ratio of the CO2 emissions (% of total fuel combustion) of Other sectors in 1973 to that in 1983?
Make the answer very short. 0.59. What is the ratio of the CO2 emissions (% of total fuel combustion) of Resident buildings and public services in 1973 to that in 1983?
Your answer should be compact. 0.96. What is the ratio of the CO2 emissions (% of total fuel combustion) of Transport in 1973 to that in 1983?
Keep it short and to the point. 0.7. What is the ratio of the CO2 emissions (% of total fuel combustion) of Other sectors in 1973 to that in 1986?
Give a very brief answer. 1.92. What is the ratio of the CO2 emissions (% of total fuel combustion) in Resident buildings and public services in 1973 to that in 1986?
Offer a very short reply. 0.83. What is the ratio of the CO2 emissions (% of total fuel combustion) in Transport in 1973 to that in 1986?
Provide a succinct answer. 0.68. What is the ratio of the CO2 emissions (% of total fuel combustion) in Other sectors in 1974 to that in 1975?
Your answer should be compact. 3.39. What is the ratio of the CO2 emissions (% of total fuel combustion) of Resident buildings and public services in 1974 to that in 1975?
Make the answer very short. 1.03. What is the ratio of the CO2 emissions (% of total fuel combustion) in Transport in 1974 to that in 1975?
Ensure brevity in your answer.  1.02. What is the ratio of the CO2 emissions (% of total fuel combustion) in Other sectors in 1974 to that in 1976?
Your response must be concise. 3.47. What is the ratio of the CO2 emissions (% of total fuel combustion) of Resident buildings and public services in 1974 to that in 1976?
Provide a succinct answer. 0.96. What is the ratio of the CO2 emissions (% of total fuel combustion) in Transport in 1974 to that in 1976?
Offer a terse response. 0.92. What is the ratio of the CO2 emissions (% of total fuel combustion) of Other sectors in 1974 to that in 1978?
Make the answer very short. 3.69. What is the ratio of the CO2 emissions (% of total fuel combustion) of Resident buildings and public services in 1974 to that in 1978?
Give a very brief answer. 0.82. What is the ratio of the CO2 emissions (% of total fuel combustion) in Transport in 1974 to that in 1978?
Make the answer very short. 0.79. What is the ratio of the CO2 emissions (% of total fuel combustion) of Other sectors in 1974 to that in 1983?
Ensure brevity in your answer.  0.9. What is the ratio of the CO2 emissions (% of total fuel combustion) in Resident buildings and public services in 1974 to that in 1983?
Your response must be concise. 0.75. What is the ratio of the CO2 emissions (% of total fuel combustion) in Transport in 1974 to that in 1983?
Make the answer very short. 0.73. What is the ratio of the CO2 emissions (% of total fuel combustion) of Other sectors in 1974 to that in 1986?
Ensure brevity in your answer.  2.93. What is the ratio of the CO2 emissions (% of total fuel combustion) in Resident buildings and public services in 1974 to that in 1986?
Provide a short and direct response. 0.65. What is the ratio of the CO2 emissions (% of total fuel combustion) in Transport in 1974 to that in 1986?
Offer a very short reply. 0.71. What is the ratio of the CO2 emissions (% of total fuel combustion) in Other sectors in 1975 to that in 1976?
Your response must be concise. 1.02. What is the ratio of the CO2 emissions (% of total fuel combustion) of Resident buildings and public services in 1975 to that in 1976?
Provide a succinct answer. 0.94. What is the ratio of the CO2 emissions (% of total fuel combustion) in Transport in 1975 to that in 1976?
Your response must be concise. 0.89. What is the ratio of the CO2 emissions (% of total fuel combustion) of Other sectors in 1975 to that in 1978?
Keep it short and to the point. 1.09. What is the ratio of the CO2 emissions (% of total fuel combustion) in Resident buildings and public services in 1975 to that in 1978?
Make the answer very short. 0.8. What is the ratio of the CO2 emissions (% of total fuel combustion) in Transport in 1975 to that in 1978?
Your answer should be compact. 0.77. What is the ratio of the CO2 emissions (% of total fuel combustion) of Other sectors in 1975 to that in 1983?
Give a very brief answer. 0.27. What is the ratio of the CO2 emissions (% of total fuel combustion) of Resident buildings and public services in 1975 to that in 1983?
Make the answer very short. 0.73. What is the ratio of the CO2 emissions (% of total fuel combustion) in Transport in 1975 to that in 1983?
Your answer should be very brief. 0.72. What is the ratio of the CO2 emissions (% of total fuel combustion) of Other sectors in 1975 to that in 1986?
Make the answer very short. 0.87. What is the ratio of the CO2 emissions (% of total fuel combustion) in Resident buildings and public services in 1975 to that in 1986?
Offer a terse response. 0.63. What is the ratio of the CO2 emissions (% of total fuel combustion) of Transport in 1975 to that in 1986?
Give a very brief answer. 0.69. What is the ratio of the CO2 emissions (% of total fuel combustion) of Other sectors in 1976 to that in 1978?
Provide a short and direct response. 1.06. What is the ratio of the CO2 emissions (% of total fuel combustion) in Resident buildings and public services in 1976 to that in 1978?
Offer a terse response. 0.85. What is the ratio of the CO2 emissions (% of total fuel combustion) of Transport in 1976 to that in 1978?
Offer a very short reply. 0.86. What is the ratio of the CO2 emissions (% of total fuel combustion) in Other sectors in 1976 to that in 1983?
Keep it short and to the point. 0.26. What is the ratio of the CO2 emissions (% of total fuel combustion) in Resident buildings and public services in 1976 to that in 1983?
Offer a very short reply. 0.78. What is the ratio of the CO2 emissions (% of total fuel combustion) in Transport in 1976 to that in 1983?
Offer a terse response. 0.8. What is the ratio of the CO2 emissions (% of total fuel combustion) in Other sectors in 1976 to that in 1986?
Give a very brief answer. 0.84. What is the ratio of the CO2 emissions (% of total fuel combustion) of Resident buildings and public services in 1976 to that in 1986?
Your response must be concise. 0.68. What is the ratio of the CO2 emissions (% of total fuel combustion) of Transport in 1976 to that in 1986?
Your response must be concise. 0.77. What is the ratio of the CO2 emissions (% of total fuel combustion) of Other sectors in 1978 to that in 1983?
Offer a very short reply. 0.25. What is the ratio of the CO2 emissions (% of total fuel combustion) in Resident buildings and public services in 1978 to that in 1983?
Provide a succinct answer. 0.92. What is the ratio of the CO2 emissions (% of total fuel combustion) of Transport in 1978 to that in 1983?
Keep it short and to the point. 0.93. What is the ratio of the CO2 emissions (% of total fuel combustion) in Other sectors in 1978 to that in 1986?
Your answer should be compact. 0.79. What is the ratio of the CO2 emissions (% of total fuel combustion) in Resident buildings and public services in 1978 to that in 1986?
Offer a very short reply. 0.79. What is the ratio of the CO2 emissions (% of total fuel combustion) in Transport in 1978 to that in 1986?
Your response must be concise. 0.9. What is the ratio of the CO2 emissions (% of total fuel combustion) of Other sectors in 1983 to that in 1986?
Make the answer very short. 3.24. What is the ratio of the CO2 emissions (% of total fuel combustion) of Resident buildings and public services in 1983 to that in 1986?
Your answer should be very brief. 0.86. What is the ratio of the CO2 emissions (% of total fuel combustion) in Transport in 1983 to that in 1986?
Ensure brevity in your answer.  0.97. What is the difference between the highest and the second highest CO2 emissions (% of total fuel combustion) of Other sectors?
Provide a short and direct response. 0.02. What is the difference between the highest and the second highest CO2 emissions (% of total fuel combustion) in Resident buildings and public services?
Give a very brief answer. 0.03. What is the difference between the highest and the second highest CO2 emissions (% of total fuel combustion) of Transport?
Ensure brevity in your answer.  1.85. What is the difference between the highest and the lowest CO2 emissions (% of total fuel combustion) in Other sectors?
Provide a succinct answer. 1.41. What is the difference between the highest and the lowest CO2 emissions (% of total fuel combustion) in Resident buildings and public services?
Ensure brevity in your answer.  3.15. What is the difference between the highest and the lowest CO2 emissions (% of total fuel combustion) of Transport?
Offer a terse response. 17.56. 